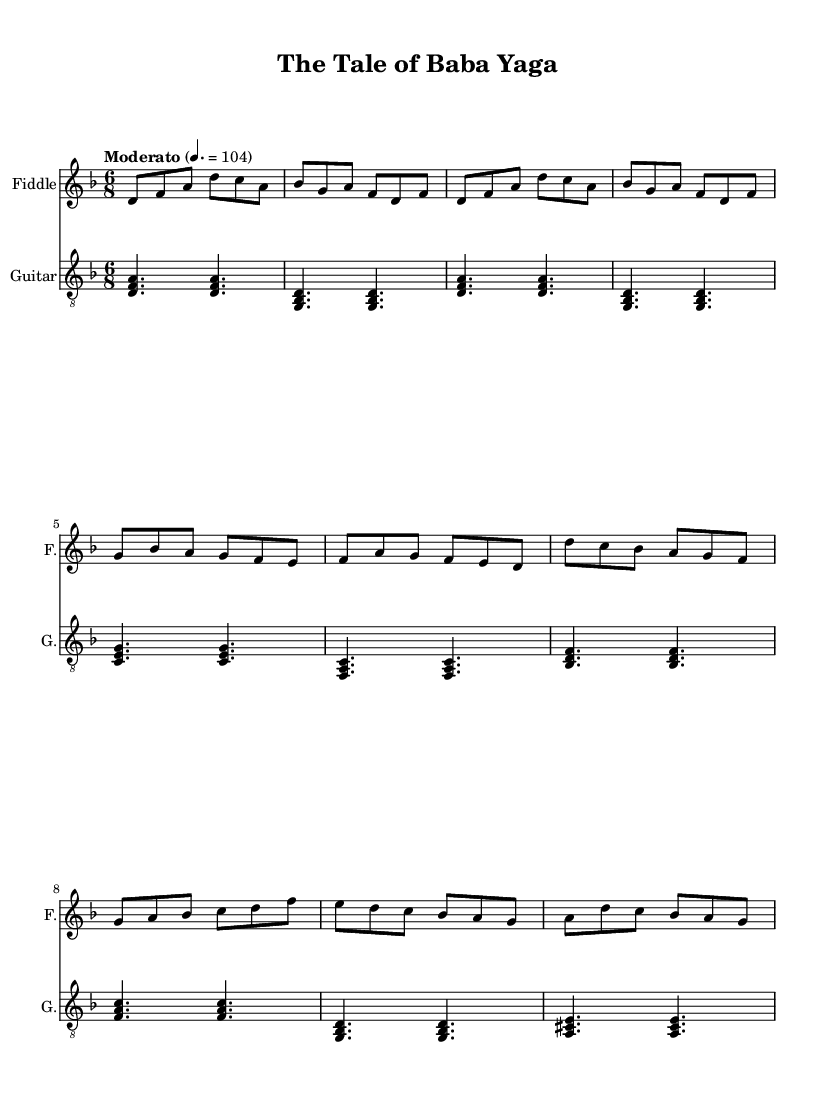What is the key signature of this music? The key signature is indicated at the beginning of the score and shows that there is one flat, which corresponds to D minor.
Answer: D minor What is the time signature of this piece? The time signature is present at the start of the score and indicates that there are six beats in a measure, with the eighth note getting one beat.
Answer: 6/8 What is the tempo marking for this music? The tempo marking is found at the beginning of the score and indicates a moderate speed of 104 beats per minute.
Answer: Moderato How many measures are in the verse section? By counting the measures in the verse section on the sheet music, we find there are four measures labeled for the verse.
Answer: 4 What is the instrument that accompanies the fiddle? The score clearly shows that alongside the fiddle, there is a guitar part as indicated in the instrument names.
Answer: Guitar Which melodic structure is used in the chorus compared to the verse? The chorus structure features a different melodic line compared to the verse but maintains the same 6/8 rhythmic feel; both parts must be analyzed for note patterns.
Answer: Different melodic line What characteristic typically found in Folk music is demonstrated in this piece? The piece exhibits features of Folk music through its use of traditional storytelling themes, as indicated by the title, which suggests a narrative quality common in Folk tales.
Answer: Traditional storytelling 